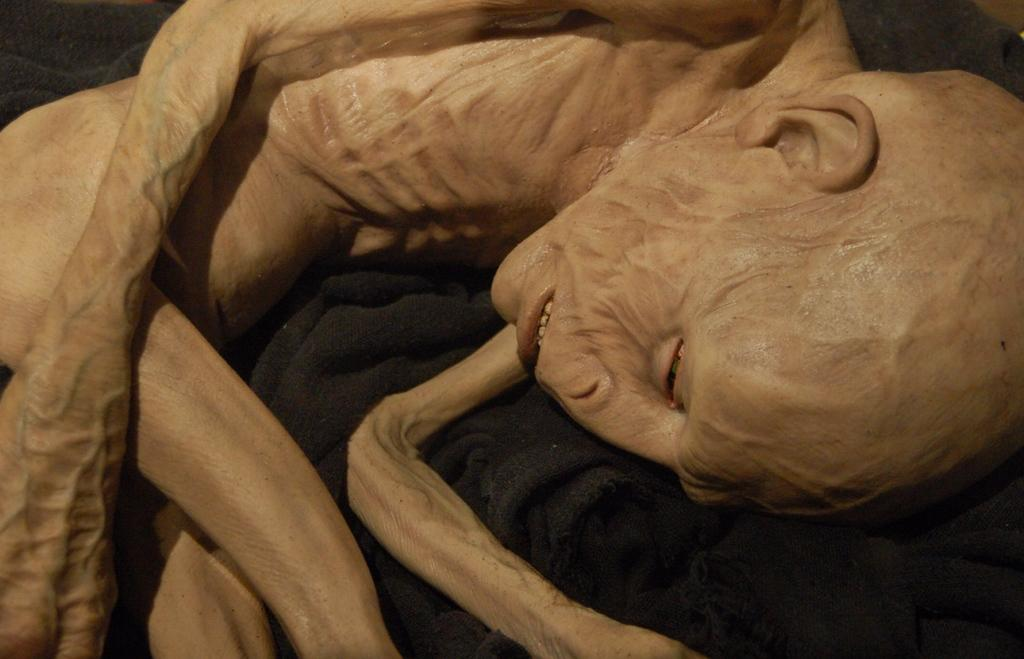What is the condition of the person in the image? There is a diseased human in the image. What object can be seen in the image besides the person? There is a black cloth in the image. What type of shoe is the army wearing while climbing the slope in the image? There is no army, shoe, or slope present in the image. 